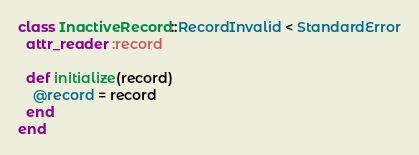Convert code to text. <code><loc_0><loc_0><loc_500><loc_500><_Ruby_>class InactiveRecord::RecordInvalid < StandardError
  attr_reader :record
  
  def initialize(record)
    @record = record
  end
end
</code> 